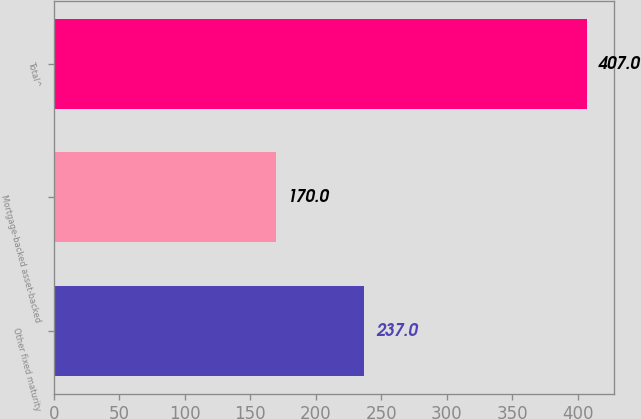<chart> <loc_0><loc_0><loc_500><loc_500><bar_chart><fcel>Other fixed maturity<fcel>Mortgage-backed asset-backed<fcel>Total^<nl><fcel>237<fcel>170<fcel>407<nl></chart> 